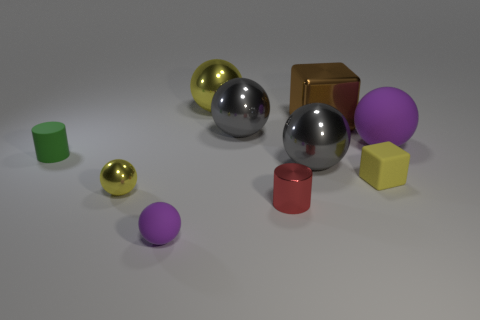The big gray thing that is to the left of the tiny metallic object that is to the right of the yellow shiny sphere in front of the large yellow sphere is made of what material?
Provide a short and direct response. Metal. What size is the brown object that is made of the same material as the tiny yellow ball?
Offer a very short reply. Large. Is there a small rubber sphere that has the same color as the big matte thing?
Offer a terse response. Yes. There is a yellow cube; does it have the same size as the red object on the left side of the yellow rubber cube?
Keep it short and to the point. Yes. What number of brown metallic blocks are in front of the large metallic block that is behind the purple rubber ball to the left of the tiny rubber cube?
Your answer should be compact. 0. There is a cube that is the same color as the small metal sphere; what size is it?
Make the answer very short. Small. There is a small shiny sphere; are there any green matte cylinders in front of it?
Keep it short and to the point. No. The big brown thing has what shape?
Give a very brief answer. Cube. What is the shape of the purple rubber object that is in front of the rubber ball that is right of the yellow shiny object behind the tiny yellow rubber cube?
Your response must be concise. Sphere. How many other things are the same shape as the big brown object?
Provide a short and direct response. 1. 